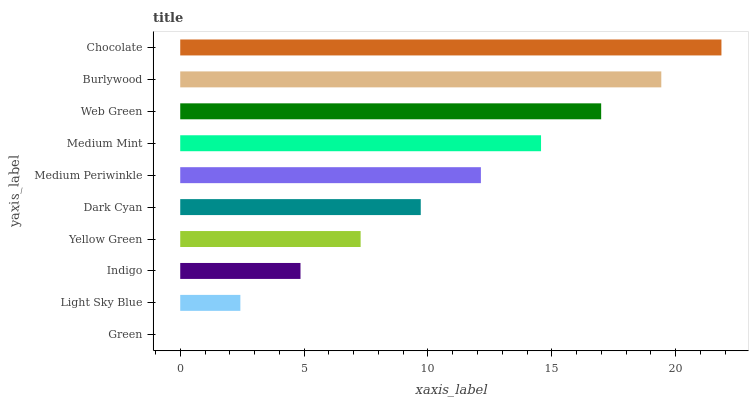Is Green the minimum?
Answer yes or no. Yes. Is Chocolate the maximum?
Answer yes or no. Yes. Is Light Sky Blue the minimum?
Answer yes or no. No. Is Light Sky Blue the maximum?
Answer yes or no. No. Is Light Sky Blue greater than Green?
Answer yes or no. Yes. Is Green less than Light Sky Blue?
Answer yes or no. Yes. Is Green greater than Light Sky Blue?
Answer yes or no. No. Is Light Sky Blue less than Green?
Answer yes or no. No. Is Medium Periwinkle the high median?
Answer yes or no. Yes. Is Dark Cyan the low median?
Answer yes or no. Yes. Is Yellow Green the high median?
Answer yes or no. No. Is Web Green the low median?
Answer yes or no. No. 